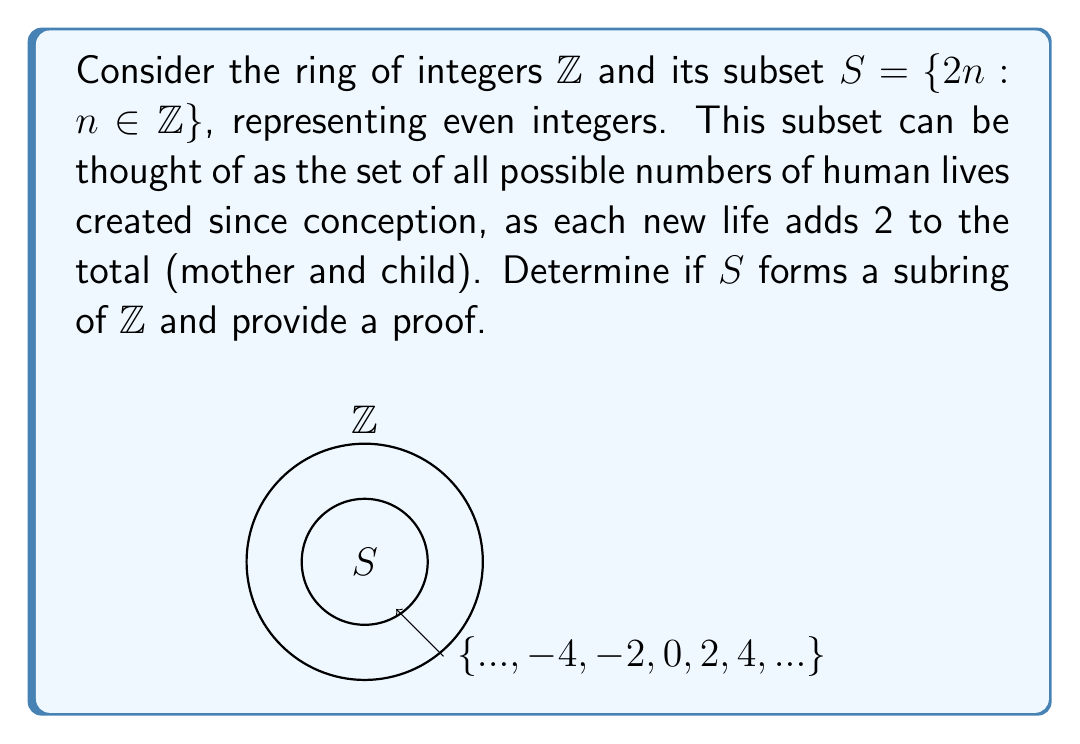Help me with this question. To prove that $S$ is a subring of $\mathbb{Z}$, we need to show that it satisfies three conditions:

1. Closure under addition: For any $a,b \in S$, $a+b \in S$
2. Closure under multiplication: For any $a,b \in S$, $ab \in S$
3. Contains the multiplicative identity: $1 \in S$

Let's check each condition:

1. Closure under addition:
   Let $a,b \in S$. Then $a=2m$ and $b=2n$ for some $m,n \in \mathbb{Z}$.
   $a+b = 2m+2n = 2(m+n)$
   Since $m+n \in \mathbb{Z}$, we have $a+b \in S$.

2. Closure under multiplication:
   Let $a,b \in S$. Then $a=2m$ and $b=2n$ for some $m,n \in \mathbb{Z}$.
   $ab = (2m)(2n) = 4mn = 2(2mn)$
   Since $2mn \in \mathbb{Z}$, we have $ab \in S$.

3. Contains the multiplicative identity:
   The multiplicative identity of $\mathbb{Z}$ is 1.
   However, $1 \notin S$ because 1 is not an even integer.

Since condition 3 is not satisfied, $S$ does not form a subring of $\mathbb{Z}$.
Answer: No, $S$ is not a subring of $\mathbb{Z}$. 